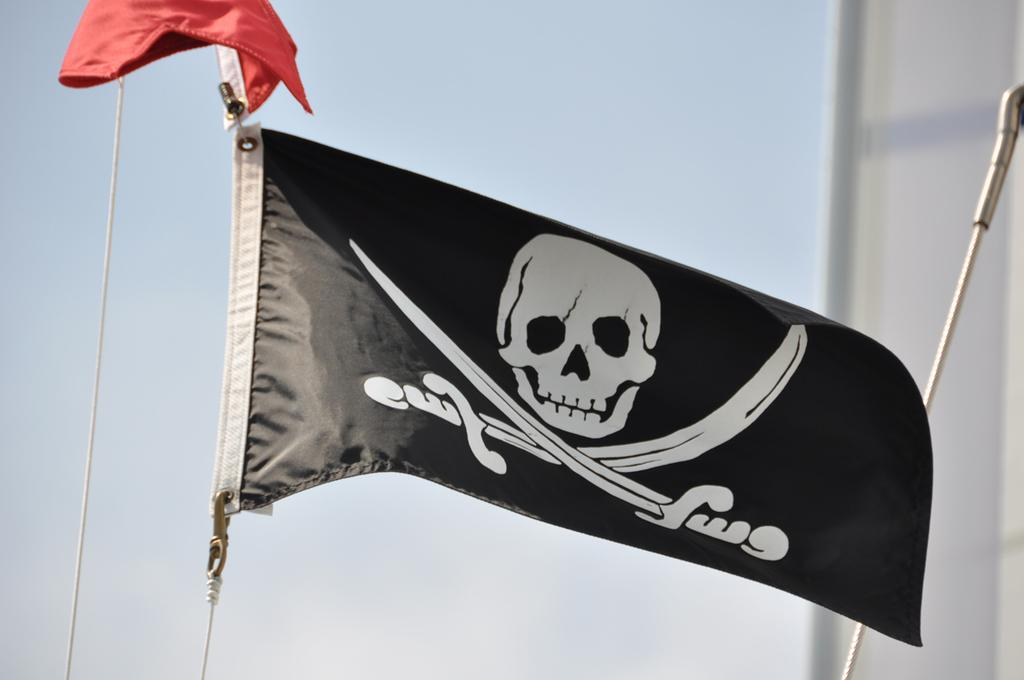What type of flag is visible in the image? There is a pirate flag in the image. What object can be seen in the image that is often used for tying or securing things? There is a rope in the image. How would you describe the background of the image? The background of the image is blurred. What is the weather like in the image? It is sunny in the image. What type of art can be seen on the ice in the image? There is no ice present in the image, and therefore no art on ice can be observed. 